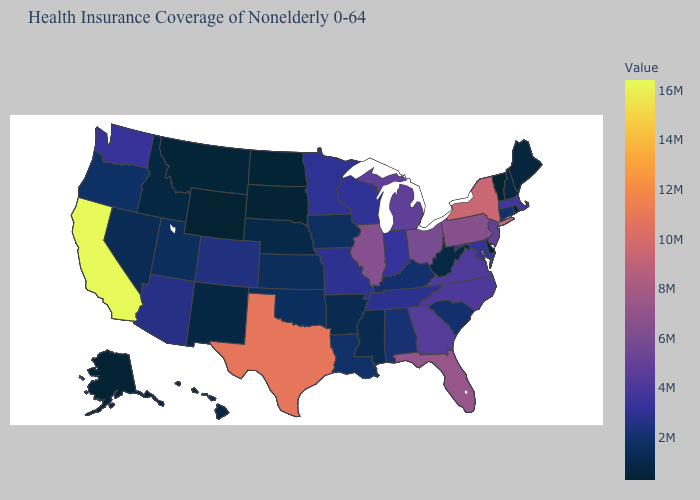Does Wyoming have the lowest value in the West?
Be succinct. Yes. Among the states that border Massachusetts , does Vermont have the lowest value?
Keep it brief. Yes. 